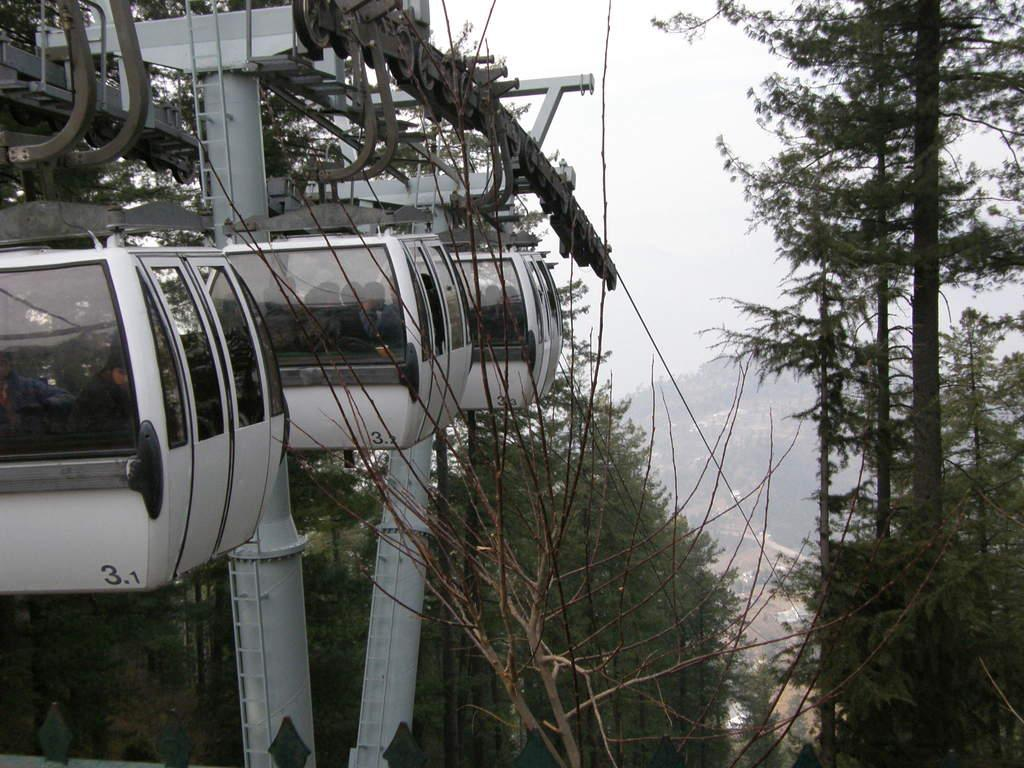What type of transportation is featured in the image? There are cable cars in the image. What else can be seen in the image besides the cable cars? There are trees in the image. Can you describe the people inside the cable cars? There are people inside the cable cars. What is visible in the background of the image? The sky is visible in the background of the image. What type of pin is holding the cable car together in the image? There is no pin visible in the image; the cable cars are held together by other means. How many teeth can be seen in the mouth of the person inside the cable car in the image? There is no person's mouth visible in the image, so it is not possible to determine the number of teeth. 